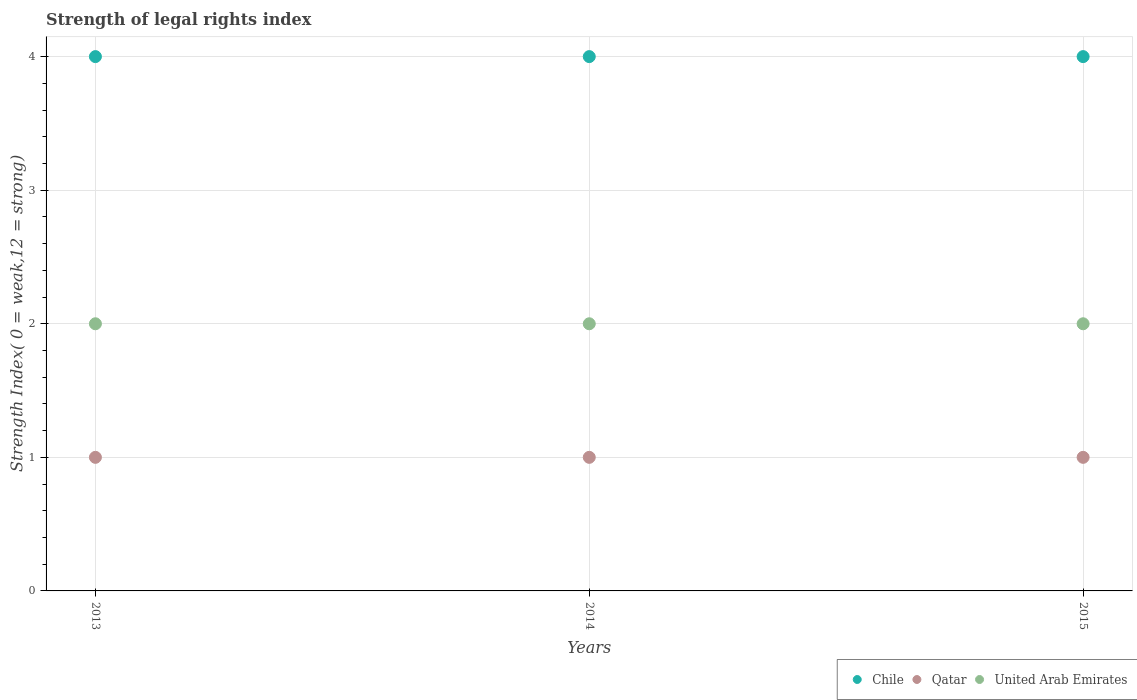What is the strength index in Chile in 2013?
Make the answer very short. 4. Across all years, what is the maximum strength index in United Arab Emirates?
Give a very brief answer. 2. Across all years, what is the minimum strength index in Chile?
Offer a very short reply. 4. What is the total strength index in Chile in the graph?
Provide a succinct answer. 12. What is the difference between the strength index in United Arab Emirates in 2013 and that in 2014?
Provide a succinct answer. 0. What is the difference between the strength index in Chile in 2015 and the strength index in Qatar in 2013?
Your answer should be very brief. 3. What is the average strength index in Chile per year?
Offer a very short reply. 4. In the year 2015, what is the difference between the strength index in Chile and strength index in Qatar?
Provide a succinct answer. 3. In how many years, is the strength index in Qatar greater than 3.8?
Offer a terse response. 0. Is the difference between the strength index in Chile in 2013 and 2015 greater than the difference between the strength index in Qatar in 2013 and 2015?
Provide a short and direct response. No. What is the difference between the highest and the lowest strength index in Chile?
Offer a terse response. 0. In how many years, is the strength index in United Arab Emirates greater than the average strength index in United Arab Emirates taken over all years?
Keep it short and to the point. 0. Is the sum of the strength index in Qatar in 2014 and 2015 greater than the maximum strength index in Chile across all years?
Your response must be concise. No. Does the strength index in Chile monotonically increase over the years?
Your response must be concise. No. How many dotlines are there?
Provide a succinct answer. 3. How many years are there in the graph?
Your answer should be very brief. 3. What is the difference between two consecutive major ticks on the Y-axis?
Your response must be concise. 1. Are the values on the major ticks of Y-axis written in scientific E-notation?
Your answer should be compact. No. Does the graph contain any zero values?
Provide a short and direct response. No. Does the graph contain grids?
Ensure brevity in your answer.  Yes. How many legend labels are there?
Your response must be concise. 3. How are the legend labels stacked?
Ensure brevity in your answer.  Horizontal. What is the title of the graph?
Offer a terse response. Strength of legal rights index. Does "Liechtenstein" appear as one of the legend labels in the graph?
Make the answer very short. No. What is the label or title of the X-axis?
Provide a short and direct response. Years. What is the label or title of the Y-axis?
Ensure brevity in your answer.  Strength Index( 0 = weak,12 = strong). What is the Strength Index( 0 = weak,12 = strong) in Chile in 2013?
Keep it short and to the point. 4. What is the Strength Index( 0 = weak,12 = strong) in Qatar in 2013?
Your answer should be very brief. 1. What is the Strength Index( 0 = weak,12 = strong) of Qatar in 2014?
Make the answer very short. 1. What is the Strength Index( 0 = weak,12 = strong) of Chile in 2015?
Provide a succinct answer. 4. What is the Strength Index( 0 = weak,12 = strong) of Qatar in 2015?
Your response must be concise. 1. What is the Strength Index( 0 = weak,12 = strong) in United Arab Emirates in 2015?
Provide a short and direct response. 2. Across all years, what is the maximum Strength Index( 0 = weak,12 = strong) of Chile?
Offer a terse response. 4. Across all years, what is the minimum Strength Index( 0 = weak,12 = strong) of Chile?
Your answer should be very brief. 4. What is the total Strength Index( 0 = weak,12 = strong) of Qatar in the graph?
Make the answer very short. 3. What is the total Strength Index( 0 = weak,12 = strong) of United Arab Emirates in the graph?
Offer a very short reply. 6. What is the difference between the Strength Index( 0 = weak,12 = strong) in Chile in 2013 and that in 2014?
Offer a very short reply. 0. What is the difference between the Strength Index( 0 = weak,12 = strong) in Chile in 2013 and that in 2015?
Offer a terse response. 0. What is the difference between the Strength Index( 0 = weak,12 = strong) in Qatar in 2014 and that in 2015?
Make the answer very short. 0. What is the difference between the Strength Index( 0 = weak,12 = strong) of Chile in 2013 and the Strength Index( 0 = weak,12 = strong) of United Arab Emirates in 2015?
Keep it short and to the point. 2. What is the difference between the Strength Index( 0 = weak,12 = strong) of Qatar in 2013 and the Strength Index( 0 = weak,12 = strong) of United Arab Emirates in 2015?
Make the answer very short. -1. What is the difference between the Strength Index( 0 = weak,12 = strong) in Chile in 2014 and the Strength Index( 0 = weak,12 = strong) in Qatar in 2015?
Your answer should be very brief. 3. What is the difference between the Strength Index( 0 = weak,12 = strong) in Qatar in 2014 and the Strength Index( 0 = weak,12 = strong) in United Arab Emirates in 2015?
Offer a very short reply. -1. What is the average Strength Index( 0 = weak,12 = strong) in Chile per year?
Provide a short and direct response. 4. What is the average Strength Index( 0 = weak,12 = strong) in Qatar per year?
Offer a very short reply. 1. What is the average Strength Index( 0 = weak,12 = strong) in United Arab Emirates per year?
Your answer should be compact. 2. In the year 2013, what is the difference between the Strength Index( 0 = weak,12 = strong) of Chile and Strength Index( 0 = weak,12 = strong) of Qatar?
Ensure brevity in your answer.  3. In the year 2013, what is the difference between the Strength Index( 0 = weak,12 = strong) of Chile and Strength Index( 0 = weak,12 = strong) of United Arab Emirates?
Provide a short and direct response. 2. In the year 2014, what is the difference between the Strength Index( 0 = weak,12 = strong) in Chile and Strength Index( 0 = weak,12 = strong) in Qatar?
Give a very brief answer. 3. In the year 2014, what is the difference between the Strength Index( 0 = weak,12 = strong) of Chile and Strength Index( 0 = weak,12 = strong) of United Arab Emirates?
Offer a very short reply. 2. In the year 2014, what is the difference between the Strength Index( 0 = weak,12 = strong) of Qatar and Strength Index( 0 = weak,12 = strong) of United Arab Emirates?
Provide a short and direct response. -1. In the year 2015, what is the difference between the Strength Index( 0 = weak,12 = strong) of Chile and Strength Index( 0 = weak,12 = strong) of Qatar?
Provide a succinct answer. 3. In the year 2015, what is the difference between the Strength Index( 0 = weak,12 = strong) in Chile and Strength Index( 0 = weak,12 = strong) in United Arab Emirates?
Give a very brief answer. 2. What is the ratio of the Strength Index( 0 = weak,12 = strong) in Chile in 2013 to that in 2015?
Your response must be concise. 1. What is the difference between the highest and the second highest Strength Index( 0 = weak,12 = strong) in Chile?
Ensure brevity in your answer.  0. What is the difference between the highest and the second highest Strength Index( 0 = weak,12 = strong) in Qatar?
Ensure brevity in your answer.  0. What is the difference between the highest and the lowest Strength Index( 0 = weak,12 = strong) in Qatar?
Offer a terse response. 0. What is the difference between the highest and the lowest Strength Index( 0 = weak,12 = strong) in United Arab Emirates?
Make the answer very short. 0. 